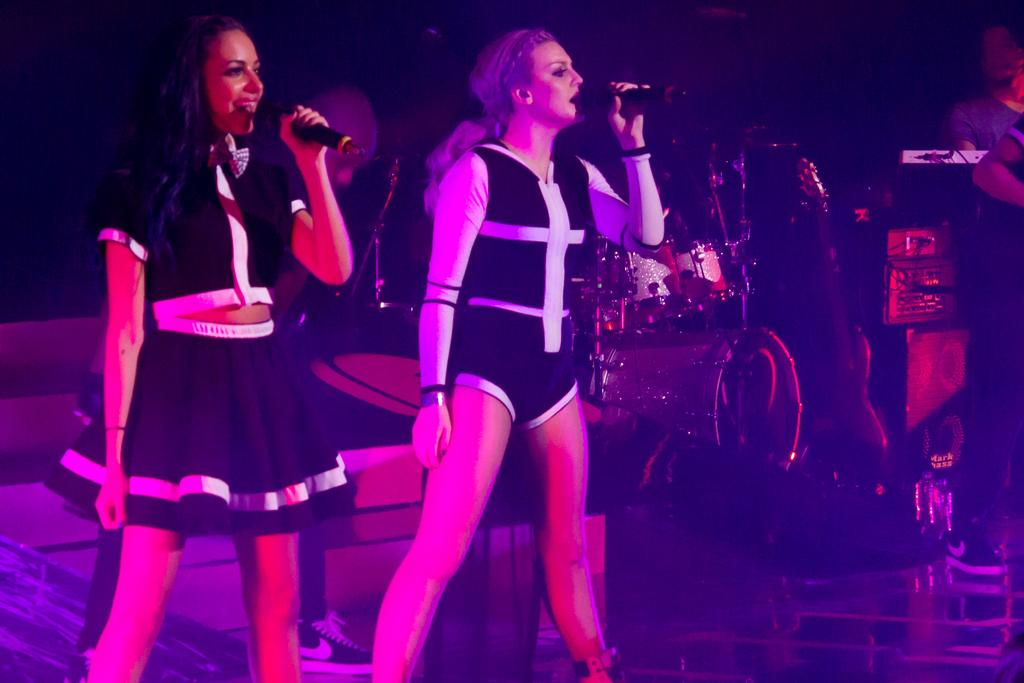How many women are in the image? There are two women in the image. What are the women doing in the image? The women are standing and holding microphones. What can be seen in the background of the image? There is a dark view, musical instruments, people, boxes, and other objects in the background of the image. What type of quartz can be seen on the microphone stands in the image? There is no quartz present in the image, and the microphone stands are not mentioned in the provided facts. 